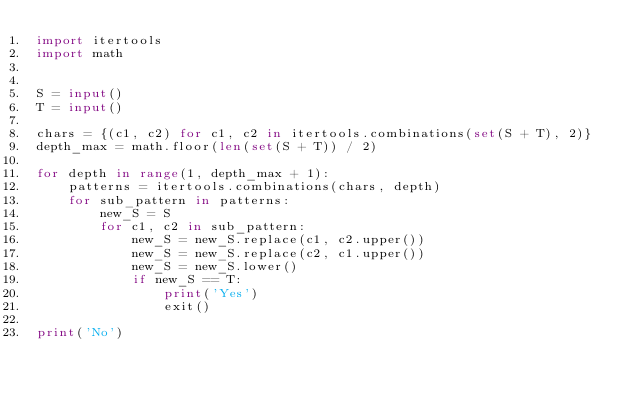Convert code to text. <code><loc_0><loc_0><loc_500><loc_500><_Python_>import itertools
import math


S = input()
T = input()

chars = {(c1, c2) for c1, c2 in itertools.combinations(set(S + T), 2)}
depth_max = math.floor(len(set(S + T)) / 2)

for depth in range(1, depth_max + 1):
    patterns = itertools.combinations(chars, depth)
    for sub_pattern in patterns:
        new_S = S
        for c1, c2 in sub_pattern:
            new_S = new_S.replace(c1, c2.upper())
            new_S = new_S.replace(c2, c1.upper())
            new_S = new_S.lower()
            if new_S == T:
                print('Yes')
                exit()

print('No')
</code> 